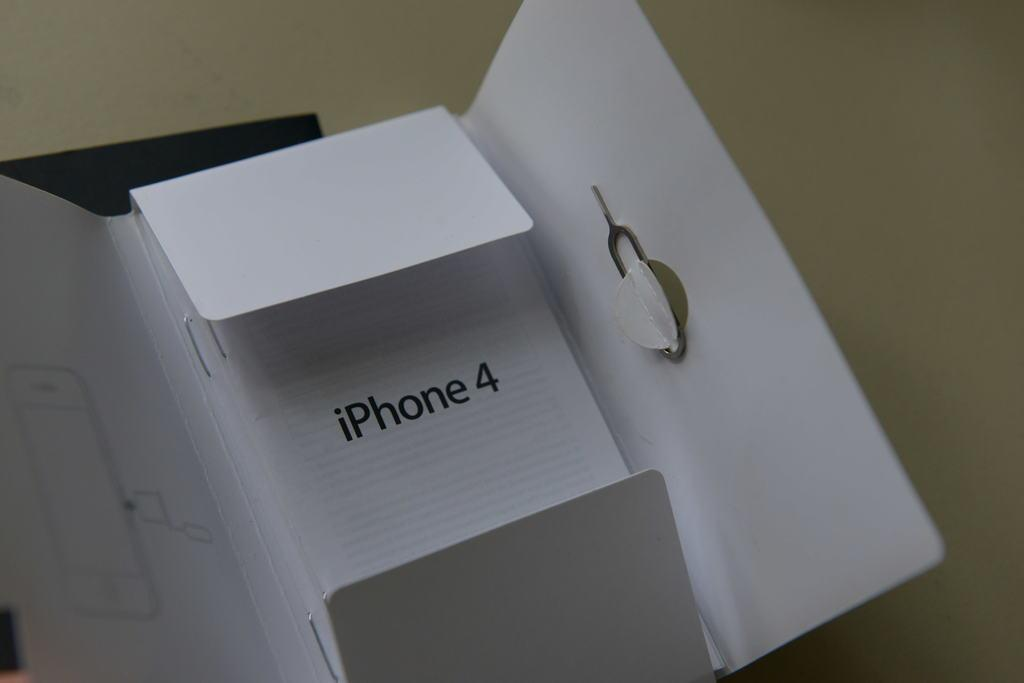<image>
Offer a succinct explanation of the picture presented. A box for the iPhone4 is open on a table. 